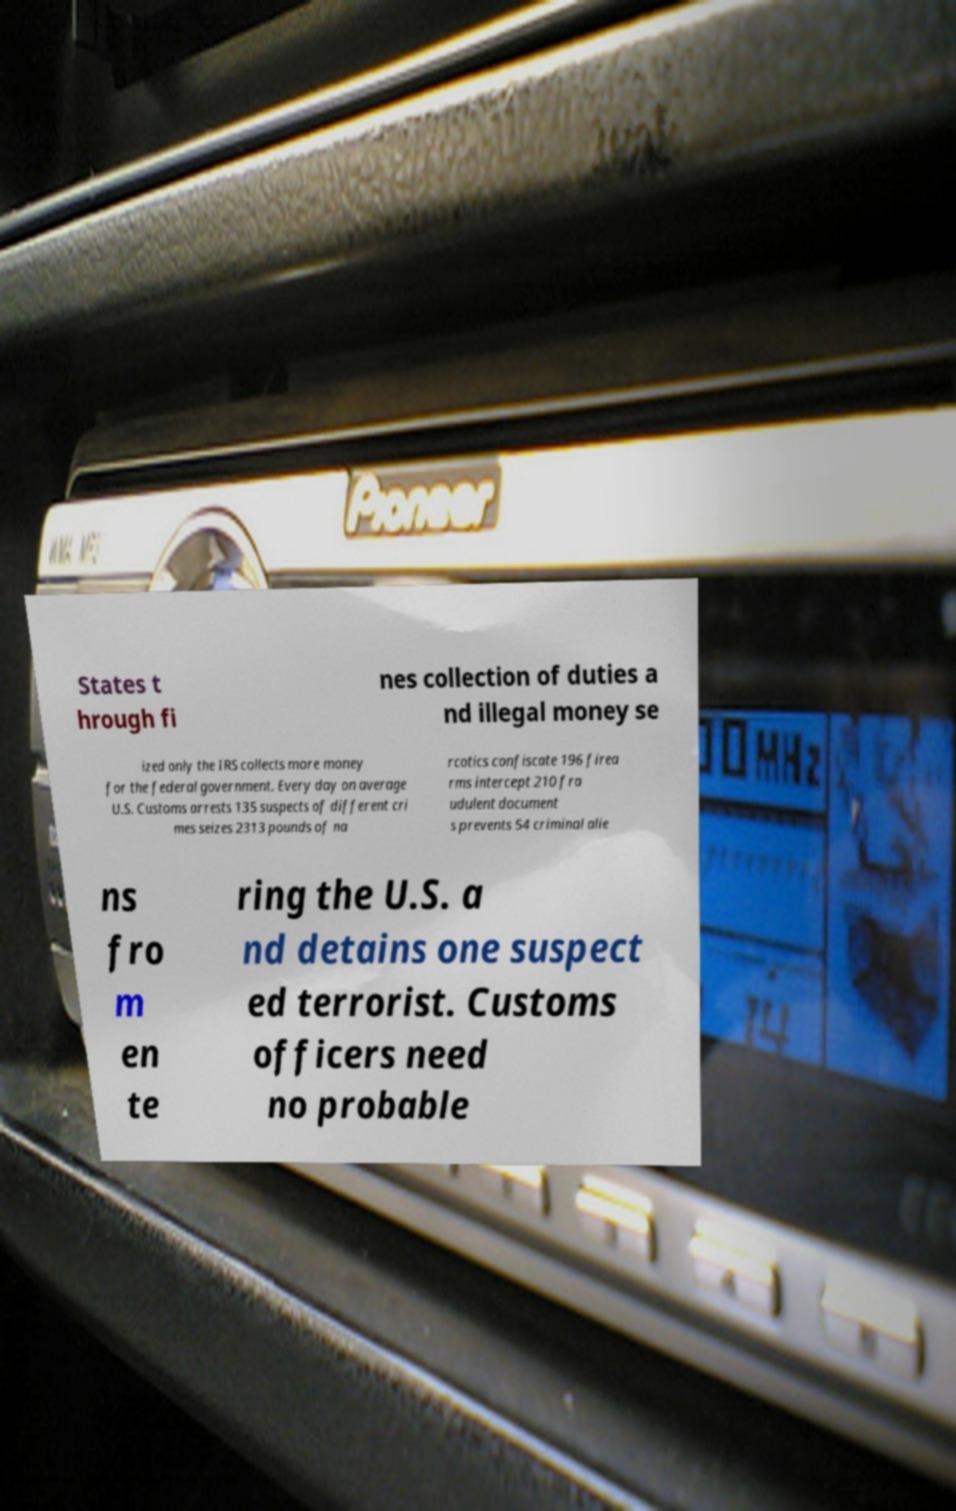What messages or text are displayed in this image? I need them in a readable, typed format. States t hrough fi nes collection of duties a nd illegal money se ized only the IRS collects more money for the federal government. Every day on average U.S. Customs arrests 135 suspects of different cri mes seizes 2313 pounds of na rcotics confiscate 196 firea rms intercept 210 fra udulent document s prevents 54 criminal alie ns fro m en te ring the U.S. a nd detains one suspect ed terrorist. Customs officers need no probable 